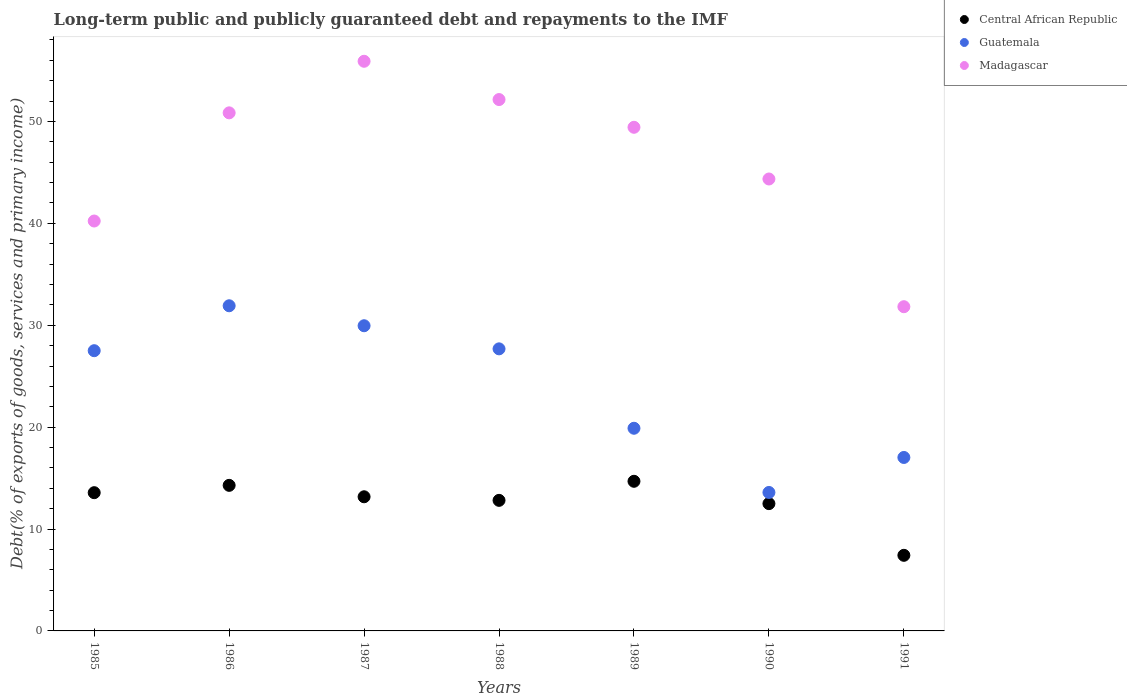What is the debt and repayments in Guatemala in 1990?
Provide a short and direct response. 13.59. Across all years, what is the maximum debt and repayments in Madagascar?
Make the answer very short. 55.91. Across all years, what is the minimum debt and repayments in Central African Republic?
Make the answer very short. 7.42. In which year was the debt and repayments in Madagascar maximum?
Ensure brevity in your answer.  1987. What is the total debt and repayments in Guatemala in the graph?
Keep it short and to the point. 167.56. What is the difference between the debt and repayments in Madagascar in 1987 and that in 1990?
Your response must be concise. 11.55. What is the difference between the debt and repayments in Central African Republic in 1985 and the debt and repayments in Guatemala in 1990?
Your answer should be compact. -0.02. What is the average debt and repayments in Guatemala per year?
Give a very brief answer. 23.94. In the year 1988, what is the difference between the debt and repayments in Madagascar and debt and repayments in Central African Republic?
Give a very brief answer. 39.34. In how many years, is the debt and repayments in Madagascar greater than 34 %?
Your answer should be compact. 6. What is the ratio of the debt and repayments in Guatemala in 1986 to that in 1987?
Make the answer very short. 1.07. Is the debt and repayments in Central African Republic in 1986 less than that in 1988?
Provide a succinct answer. No. Is the difference between the debt and repayments in Madagascar in 1986 and 1988 greater than the difference between the debt and repayments in Central African Republic in 1986 and 1988?
Keep it short and to the point. No. What is the difference between the highest and the second highest debt and repayments in Madagascar?
Offer a terse response. 3.76. What is the difference between the highest and the lowest debt and repayments in Guatemala?
Ensure brevity in your answer.  18.32. Is the sum of the debt and repayments in Madagascar in 1986 and 1988 greater than the maximum debt and repayments in Guatemala across all years?
Your answer should be very brief. Yes. Does the debt and repayments in Central African Republic monotonically increase over the years?
Your response must be concise. No. How many dotlines are there?
Provide a short and direct response. 3. What is the difference between two consecutive major ticks on the Y-axis?
Your answer should be compact. 10. Are the values on the major ticks of Y-axis written in scientific E-notation?
Provide a succinct answer. No. Does the graph contain any zero values?
Ensure brevity in your answer.  No. Where does the legend appear in the graph?
Provide a short and direct response. Top right. How are the legend labels stacked?
Your answer should be compact. Vertical. What is the title of the graph?
Your answer should be compact. Long-term public and publicly guaranteed debt and repayments to the IMF. Does "Other small states" appear as one of the legend labels in the graph?
Make the answer very short. No. What is the label or title of the Y-axis?
Make the answer very short. Debt(% of exports of goods, services and primary income). What is the Debt(% of exports of goods, services and primary income) in Central African Republic in 1985?
Your answer should be very brief. 13.57. What is the Debt(% of exports of goods, services and primary income) of Guatemala in 1985?
Keep it short and to the point. 27.5. What is the Debt(% of exports of goods, services and primary income) of Madagascar in 1985?
Make the answer very short. 40.23. What is the Debt(% of exports of goods, services and primary income) in Central African Republic in 1986?
Provide a succinct answer. 14.29. What is the Debt(% of exports of goods, services and primary income) of Guatemala in 1986?
Your response must be concise. 31.91. What is the Debt(% of exports of goods, services and primary income) of Madagascar in 1986?
Keep it short and to the point. 50.85. What is the Debt(% of exports of goods, services and primary income) in Central African Republic in 1987?
Your answer should be very brief. 13.17. What is the Debt(% of exports of goods, services and primary income) of Guatemala in 1987?
Keep it short and to the point. 29.95. What is the Debt(% of exports of goods, services and primary income) of Madagascar in 1987?
Your response must be concise. 55.91. What is the Debt(% of exports of goods, services and primary income) of Central African Republic in 1988?
Your answer should be very brief. 12.81. What is the Debt(% of exports of goods, services and primary income) of Guatemala in 1988?
Make the answer very short. 27.68. What is the Debt(% of exports of goods, services and primary income) in Madagascar in 1988?
Offer a very short reply. 52.15. What is the Debt(% of exports of goods, services and primary income) in Central African Republic in 1989?
Make the answer very short. 14.69. What is the Debt(% of exports of goods, services and primary income) of Guatemala in 1989?
Make the answer very short. 19.89. What is the Debt(% of exports of goods, services and primary income) of Madagascar in 1989?
Keep it short and to the point. 49.43. What is the Debt(% of exports of goods, services and primary income) in Central African Republic in 1990?
Your answer should be very brief. 12.49. What is the Debt(% of exports of goods, services and primary income) of Guatemala in 1990?
Provide a succinct answer. 13.59. What is the Debt(% of exports of goods, services and primary income) in Madagascar in 1990?
Your response must be concise. 44.36. What is the Debt(% of exports of goods, services and primary income) in Central African Republic in 1991?
Your answer should be very brief. 7.42. What is the Debt(% of exports of goods, services and primary income) in Guatemala in 1991?
Your answer should be compact. 17.02. What is the Debt(% of exports of goods, services and primary income) in Madagascar in 1991?
Make the answer very short. 31.82. Across all years, what is the maximum Debt(% of exports of goods, services and primary income) in Central African Republic?
Offer a very short reply. 14.69. Across all years, what is the maximum Debt(% of exports of goods, services and primary income) in Guatemala?
Your answer should be compact. 31.91. Across all years, what is the maximum Debt(% of exports of goods, services and primary income) of Madagascar?
Your answer should be very brief. 55.91. Across all years, what is the minimum Debt(% of exports of goods, services and primary income) in Central African Republic?
Your answer should be compact. 7.42. Across all years, what is the minimum Debt(% of exports of goods, services and primary income) in Guatemala?
Provide a succinct answer. 13.59. Across all years, what is the minimum Debt(% of exports of goods, services and primary income) of Madagascar?
Make the answer very short. 31.82. What is the total Debt(% of exports of goods, services and primary income) in Central African Republic in the graph?
Give a very brief answer. 88.44. What is the total Debt(% of exports of goods, services and primary income) in Guatemala in the graph?
Offer a terse response. 167.56. What is the total Debt(% of exports of goods, services and primary income) of Madagascar in the graph?
Ensure brevity in your answer.  324.75. What is the difference between the Debt(% of exports of goods, services and primary income) in Central African Republic in 1985 and that in 1986?
Give a very brief answer. -0.72. What is the difference between the Debt(% of exports of goods, services and primary income) in Guatemala in 1985 and that in 1986?
Your answer should be very brief. -4.41. What is the difference between the Debt(% of exports of goods, services and primary income) in Madagascar in 1985 and that in 1986?
Your answer should be very brief. -10.62. What is the difference between the Debt(% of exports of goods, services and primary income) in Central African Republic in 1985 and that in 1987?
Ensure brevity in your answer.  0.4. What is the difference between the Debt(% of exports of goods, services and primary income) of Guatemala in 1985 and that in 1987?
Your answer should be compact. -2.45. What is the difference between the Debt(% of exports of goods, services and primary income) in Madagascar in 1985 and that in 1987?
Make the answer very short. -15.68. What is the difference between the Debt(% of exports of goods, services and primary income) of Central African Republic in 1985 and that in 1988?
Provide a short and direct response. 0.75. What is the difference between the Debt(% of exports of goods, services and primary income) in Guatemala in 1985 and that in 1988?
Your answer should be very brief. -0.18. What is the difference between the Debt(% of exports of goods, services and primary income) of Madagascar in 1985 and that in 1988?
Your answer should be very brief. -11.92. What is the difference between the Debt(% of exports of goods, services and primary income) of Central African Republic in 1985 and that in 1989?
Provide a succinct answer. -1.12. What is the difference between the Debt(% of exports of goods, services and primary income) of Guatemala in 1985 and that in 1989?
Offer a terse response. 7.61. What is the difference between the Debt(% of exports of goods, services and primary income) of Madagascar in 1985 and that in 1989?
Give a very brief answer. -9.2. What is the difference between the Debt(% of exports of goods, services and primary income) in Central African Republic in 1985 and that in 1990?
Provide a short and direct response. 1.07. What is the difference between the Debt(% of exports of goods, services and primary income) of Guatemala in 1985 and that in 1990?
Offer a terse response. 13.91. What is the difference between the Debt(% of exports of goods, services and primary income) in Madagascar in 1985 and that in 1990?
Provide a succinct answer. -4.13. What is the difference between the Debt(% of exports of goods, services and primary income) in Central African Republic in 1985 and that in 1991?
Provide a succinct answer. 6.15. What is the difference between the Debt(% of exports of goods, services and primary income) in Guatemala in 1985 and that in 1991?
Your answer should be very brief. 10.48. What is the difference between the Debt(% of exports of goods, services and primary income) of Madagascar in 1985 and that in 1991?
Keep it short and to the point. 8.41. What is the difference between the Debt(% of exports of goods, services and primary income) of Central African Republic in 1986 and that in 1987?
Your response must be concise. 1.12. What is the difference between the Debt(% of exports of goods, services and primary income) of Guatemala in 1986 and that in 1987?
Your answer should be compact. 1.96. What is the difference between the Debt(% of exports of goods, services and primary income) of Madagascar in 1986 and that in 1987?
Your response must be concise. -5.06. What is the difference between the Debt(% of exports of goods, services and primary income) in Central African Republic in 1986 and that in 1988?
Offer a very short reply. 1.47. What is the difference between the Debt(% of exports of goods, services and primary income) of Guatemala in 1986 and that in 1988?
Your answer should be compact. 4.23. What is the difference between the Debt(% of exports of goods, services and primary income) in Madagascar in 1986 and that in 1988?
Give a very brief answer. -1.31. What is the difference between the Debt(% of exports of goods, services and primary income) in Central African Republic in 1986 and that in 1989?
Your answer should be compact. -0.4. What is the difference between the Debt(% of exports of goods, services and primary income) of Guatemala in 1986 and that in 1989?
Your answer should be compact. 12.02. What is the difference between the Debt(% of exports of goods, services and primary income) in Madagascar in 1986 and that in 1989?
Offer a very short reply. 1.42. What is the difference between the Debt(% of exports of goods, services and primary income) in Central African Republic in 1986 and that in 1990?
Make the answer very short. 1.79. What is the difference between the Debt(% of exports of goods, services and primary income) of Guatemala in 1986 and that in 1990?
Provide a succinct answer. 18.32. What is the difference between the Debt(% of exports of goods, services and primary income) in Madagascar in 1986 and that in 1990?
Offer a terse response. 6.49. What is the difference between the Debt(% of exports of goods, services and primary income) of Central African Republic in 1986 and that in 1991?
Provide a short and direct response. 6.87. What is the difference between the Debt(% of exports of goods, services and primary income) in Guatemala in 1986 and that in 1991?
Offer a terse response. 14.89. What is the difference between the Debt(% of exports of goods, services and primary income) of Madagascar in 1986 and that in 1991?
Give a very brief answer. 19.03. What is the difference between the Debt(% of exports of goods, services and primary income) in Central African Republic in 1987 and that in 1988?
Provide a succinct answer. 0.35. What is the difference between the Debt(% of exports of goods, services and primary income) in Guatemala in 1987 and that in 1988?
Keep it short and to the point. 2.27. What is the difference between the Debt(% of exports of goods, services and primary income) in Madagascar in 1987 and that in 1988?
Offer a very short reply. 3.76. What is the difference between the Debt(% of exports of goods, services and primary income) in Central African Republic in 1987 and that in 1989?
Keep it short and to the point. -1.52. What is the difference between the Debt(% of exports of goods, services and primary income) in Guatemala in 1987 and that in 1989?
Keep it short and to the point. 10.06. What is the difference between the Debt(% of exports of goods, services and primary income) of Madagascar in 1987 and that in 1989?
Your answer should be very brief. 6.48. What is the difference between the Debt(% of exports of goods, services and primary income) of Central African Republic in 1987 and that in 1990?
Offer a terse response. 0.67. What is the difference between the Debt(% of exports of goods, services and primary income) in Guatemala in 1987 and that in 1990?
Give a very brief answer. 16.36. What is the difference between the Debt(% of exports of goods, services and primary income) in Madagascar in 1987 and that in 1990?
Keep it short and to the point. 11.55. What is the difference between the Debt(% of exports of goods, services and primary income) in Central African Republic in 1987 and that in 1991?
Your answer should be very brief. 5.75. What is the difference between the Debt(% of exports of goods, services and primary income) of Guatemala in 1987 and that in 1991?
Give a very brief answer. 12.93. What is the difference between the Debt(% of exports of goods, services and primary income) in Madagascar in 1987 and that in 1991?
Offer a terse response. 24.09. What is the difference between the Debt(% of exports of goods, services and primary income) of Central African Republic in 1988 and that in 1989?
Your answer should be compact. -1.87. What is the difference between the Debt(% of exports of goods, services and primary income) in Guatemala in 1988 and that in 1989?
Provide a short and direct response. 7.79. What is the difference between the Debt(% of exports of goods, services and primary income) of Madagascar in 1988 and that in 1989?
Provide a short and direct response. 2.72. What is the difference between the Debt(% of exports of goods, services and primary income) of Central African Republic in 1988 and that in 1990?
Your answer should be very brief. 0.32. What is the difference between the Debt(% of exports of goods, services and primary income) in Guatemala in 1988 and that in 1990?
Your answer should be very brief. 14.09. What is the difference between the Debt(% of exports of goods, services and primary income) of Madagascar in 1988 and that in 1990?
Provide a short and direct response. 7.8. What is the difference between the Debt(% of exports of goods, services and primary income) of Central African Republic in 1988 and that in 1991?
Make the answer very short. 5.39. What is the difference between the Debt(% of exports of goods, services and primary income) of Guatemala in 1988 and that in 1991?
Keep it short and to the point. 10.66. What is the difference between the Debt(% of exports of goods, services and primary income) of Madagascar in 1988 and that in 1991?
Your answer should be very brief. 20.33. What is the difference between the Debt(% of exports of goods, services and primary income) of Central African Republic in 1989 and that in 1990?
Provide a succinct answer. 2.19. What is the difference between the Debt(% of exports of goods, services and primary income) in Guatemala in 1989 and that in 1990?
Your answer should be very brief. 6.3. What is the difference between the Debt(% of exports of goods, services and primary income) in Madagascar in 1989 and that in 1990?
Provide a succinct answer. 5.07. What is the difference between the Debt(% of exports of goods, services and primary income) in Central African Republic in 1989 and that in 1991?
Provide a short and direct response. 7.27. What is the difference between the Debt(% of exports of goods, services and primary income) of Guatemala in 1989 and that in 1991?
Make the answer very short. 2.87. What is the difference between the Debt(% of exports of goods, services and primary income) of Madagascar in 1989 and that in 1991?
Make the answer very short. 17.61. What is the difference between the Debt(% of exports of goods, services and primary income) of Central African Republic in 1990 and that in 1991?
Keep it short and to the point. 5.07. What is the difference between the Debt(% of exports of goods, services and primary income) in Guatemala in 1990 and that in 1991?
Ensure brevity in your answer.  -3.43. What is the difference between the Debt(% of exports of goods, services and primary income) in Madagascar in 1990 and that in 1991?
Give a very brief answer. 12.54. What is the difference between the Debt(% of exports of goods, services and primary income) of Central African Republic in 1985 and the Debt(% of exports of goods, services and primary income) of Guatemala in 1986?
Make the answer very short. -18.34. What is the difference between the Debt(% of exports of goods, services and primary income) in Central African Republic in 1985 and the Debt(% of exports of goods, services and primary income) in Madagascar in 1986?
Make the answer very short. -37.28. What is the difference between the Debt(% of exports of goods, services and primary income) in Guatemala in 1985 and the Debt(% of exports of goods, services and primary income) in Madagascar in 1986?
Offer a terse response. -23.34. What is the difference between the Debt(% of exports of goods, services and primary income) of Central African Republic in 1985 and the Debt(% of exports of goods, services and primary income) of Guatemala in 1987?
Give a very brief answer. -16.38. What is the difference between the Debt(% of exports of goods, services and primary income) in Central African Republic in 1985 and the Debt(% of exports of goods, services and primary income) in Madagascar in 1987?
Ensure brevity in your answer.  -42.34. What is the difference between the Debt(% of exports of goods, services and primary income) in Guatemala in 1985 and the Debt(% of exports of goods, services and primary income) in Madagascar in 1987?
Keep it short and to the point. -28.41. What is the difference between the Debt(% of exports of goods, services and primary income) of Central African Republic in 1985 and the Debt(% of exports of goods, services and primary income) of Guatemala in 1988?
Offer a terse response. -14.12. What is the difference between the Debt(% of exports of goods, services and primary income) of Central African Republic in 1985 and the Debt(% of exports of goods, services and primary income) of Madagascar in 1988?
Provide a succinct answer. -38.59. What is the difference between the Debt(% of exports of goods, services and primary income) of Guatemala in 1985 and the Debt(% of exports of goods, services and primary income) of Madagascar in 1988?
Offer a terse response. -24.65. What is the difference between the Debt(% of exports of goods, services and primary income) of Central African Republic in 1985 and the Debt(% of exports of goods, services and primary income) of Guatemala in 1989?
Keep it short and to the point. -6.32. What is the difference between the Debt(% of exports of goods, services and primary income) of Central African Republic in 1985 and the Debt(% of exports of goods, services and primary income) of Madagascar in 1989?
Your response must be concise. -35.86. What is the difference between the Debt(% of exports of goods, services and primary income) of Guatemala in 1985 and the Debt(% of exports of goods, services and primary income) of Madagascar in 1989?
Provide a succinct answer. -21.93. What is the difference between the Debt(% of exports of goods, services and primary income) of Central African Republic in 1985 and the Debt(% of exports of goods, services and primary income) of Guatemala in 1990?
Provide a short and direct response. -0.02. What is the difference between the Debt(% of exports of goods, services and primary income) in Central African Republic in 1985 and the Debt(% of exports of goods, services and primary income) in Madagascar in 1990?
Offer a terse response. -30.79. What is the difference between the Debt(% of exports of goods, services and primary income) in Guatemala in 1985 and the Debt(% of exports of goods, services and primary income) in Madagascar in 1990?
Provide a succinct answer. -16.85. What is the difference between the Debt(% of exports of goods, services and primary income) in Central African Republic in 1985 and the Debt(% of exports of goods, services and primary income) in Guatemala in 1991?
Ensure brevity in your answer.  -3.46. What is the difference between the Debt(% of exports of goods, services and primary income) in Central African Republic in 1985 and the Debt(% of exports of goods, services and primary income) in Madagascar in 1991?
Your answer should be compact. -18.25. What is the difference between the Debt(% of exports of goods, services and primary income) of Guatemala in 1985 and the Debt(% of exports of goods, services and primary income) of Madagascar in 1991?
Ensure brevity in your answer.  -4.32. What is the difference between the Debt(% of exports of goods, services and primary income) in Central African Republic in 1986 and the Debt(% of exports of goods, services and primary income) in Guatemala in 1987?
Give a very brief answer. -15.67. What is the difference between the Debt(% of exports of goods, services and primary income) of Central African Republic in 1986 and the Debt(% of exports of goods, services and primary income) of Madagascar in 1987?
Ensure brevity in your answer.  -41.62. What is the difference between the Debt(% of exports of goods, services and primary income) of Guatemala in 1986 and the Debt(% of exports of goods, services and primary income) of Madagascar in 1987?
Your answer should be compact. -24. What is the difference between the Debt(% of exports of goods, services and primary income) in Central African Republic in 1986 and the Debt(% of exports of goods, services and primary income) in Guatemala in 1988?
Give a very brief answer. -13.4. What is the difference between the Debt(% of exports of goods, services and primary income) of Central African Republic in 1986 and the Debt(% of exports of goods, services and primary income) of Madagascar in 1988?
Ensure brevity in your answer.  -37.87. What is the difference between the Debt(% of exports of goods, services and primary income) of Guatemala in 1986 and the Debt(% of exports of goods, services and primary income) of Madagascar in 1988?
Keep it short and to the point. -20.24. What is the difference between the Debt(% of exports of goods, services and primary income) of Central African Republic in 1986 and the Debt(% of exports of goods, services and primary income) of Guatemala in 1989?
Give a very brief answer. -5.6. What is the difference between the Debt(% of exports of goods, services and primary income) in Central African Republic in 1986 and the Debt(% of exports of goods, services and primary income) in Madagascar in 1989?
Provide a succinct answer. -35.14. What is the difference between the Debt(% of exports of goods, services and primary income) in Guatemala in 1986 and the Debt(% of exports of goods, services and primary income) in Madagascar in 1989?
Provide a short and direct response. -17.52. What is the difference between the Debt(% of exports of goods, services and primary income) in Central African Republic in 1986 and the Debt(% of exports of goods, services and primary income) in Guatemala in 1990?
Ensure brevity in your answer.  0.7. What is the difference between the Debt(% of exports of goods, services and primary income) of Central African Republic in 1986 and the Debt(% of exports of goods, services and primary income) of Madagascar in 1990?
Your response must be concise. -30.07. What is the difference between the Debt(% of exports of goods, services and primary income) of Guatemala in 1986 and the Debt(% of exports of goods, services and primary income) of Madagascar in 1990?
Your answer should be compact. -12.44. What is the difference between the Debt(% of exports of goods, services and primary income) in Central African Republic in 1986 and the Debt(% of exports of goods, services and primary income) in Guatemala in 1991?
Your answer should be compact. -2.74. What is the difference between the Debt(% of exports of goods, services and primary income) in Central African Republic in 1986 and the Debt(% of exports of goods, services and primary income) in Madagascar in 1991?
Your answer should be compact. -17.53. What is the difference between the Debt(% of exports of goods, services and primary income) of Guatemala in 1986 and the Debt(% of exports of goods, services and primary income) of Madagascar in 1991?
Your response must be concise. 0.09. What is the difference between the Debt(% of exports of goods, services and primary income) in Central African Republic in 1987 and the Debt(% of exports of goods, services and primary income) in Guatemala in 1988?
Keep it short and to the point. -14.52. What is the difference between the Debt(% of exports of goods, services and primary income) in Central African Republic in 1987 and the Debt(% of exports of goods, services and primary income) in Madagascar in 1988?
Provide a short and direct response. -38.99. What is the difference between the Debt(% of exports of goods, services and primary income) in Guatemala in 1987 and the Debt(% of exports of goods, services and primary income) in Madagascar in 1988?
Your response must be concise. -22.2. What is the difference between the Debt(% of exports of goods, services and primary income) in Central African Republic in 1987 and the Debt(% of exports of goods, services and primary income) in Guatemala in 1989?
Give a very brief answer. -6.72. What is the difference between the Debt(% of exports of goods, services and primary income) of Central African Republic in 1987 and the Debt(% of exports of goods, services and primary income) of Madagascar in 1989?
Make the answer very short. -36.26. What is the difference between the Debt(% of exports of goods, services and primary income) in Guatemala in 1987 and the Debt(% of exports of goods, services and primary income) in Madagascar in 1989?
Keep it short and to the point. -19.48. What is the difference between the Debt(% of exports of goods, services and primary income) in Central African Republic in 1987 and the Debt(% of exports of goods, services and primary income) in Guatemala in 1990?
Give a very brief answer. -0.42. What is the difference between the Debt(% of exports of goods, services and primary income) in Central African Republic in 1987 and the Debt(% of exports of goods, services and primary income) in Madagascar in 1990?
Your response must be concise. -31.19. What is the difference between the Debt(% of exports of goods, services and primary income) of Guatemala in 1987 and the Debt(% of exports of goods, services and primary income) of Madagascar in 1990?
Your answer should be compact. -14.4. What is the difference between the Debt(% of exports of goods, services and primary income) of Central African Republic in 1987 and the Debt(% of exports of goods, services and primary income) of Guatemala in 1991?
Your answer should be compact. -3.86. What is the difference between the Debt(% of exports of goods, services and primary income) in Central African Republic in 1987 and the Debt(% of exports of goods, services and primary income) in Madagascar in 1991?
Keep it short and to the point. -18.65. What is the difference between the Debt(% of exports of goods, services and primary income) in Guatemala in 1987 and the Debt(% of exports of goods, services and primary income) in Madagascar in 1991?
Ensure brevity in your answer.  -1.87. What is the difference between the Debt(% of exports of goods, services and primary income) of Central African Republic in 1988 and the Debt(% of exports of goods, services and primary income) of Guatemala in 1989?
Ensure brevity in your answer.  -7.08. What is the difference between the Debt(% of exports of goods, services and primary income) of Central African Republic in 1988 and the Debt(% of exports of goods, services and primary income) of Madagascar in 1989?
Offer a very short reply. -36.62. What is the difference between the Debt(% of exports of goods, services and primary income) of Guatemala in 1988 and the Debt(% of exports of goods, services and primary income) of Madagascar in 1989?
Provide a succinct answer. -21.75. What is the difference between the Debt(% of exports of goods, services and primary income) in Central African Republic in 1988 and the Debt(% of exports of goods, services and primary income) in Guatemala in 1990?
Give a very brief answer. -0.78. What is the difference between the Debt(% of exports of goods, services and primary income) in Central African Republic in 1988 and the Debt(% of exports of goods, services and primary income) in Madagascar in 1990?
Make the answer very short. -31.54. What is the difference between the Debt(% of exports of goods, services and primary income) of Guatemala in 1988 and the Debt(% of exports of goods, services and primary income) of Madagascar in 1990?
Ensure brevity in your answer.  -16.67. What is the difference between the Debt(% of exports of goods, services and primary income) in Central African Republic in 1988 and the Debt(% of exports of goods, services and primary income) in Guatemala in 1991?
Give a very brief answer. -4.21. What is the difference between the Debt(% of exports of goods, services and primary income) in Central African Republic in 1988 and the Debt(% of exports of goods, services and primary income) in Madagascar in 1991?
Provide a succinct answer. -19.01. What is the difference between the Debt(% of exports of goods, services and primary income) in Guatemala in 1988 and the Debt(% of exports of goods, services and primary income) in Madagascar in 1991?
Offer a very short reply. -4.14. What is the difference between the Debt(% of exports of goods, services and primary income) in Central African Republic in 1989 and the Debt(% of exports of goods, services and primary income) in Guatemala in 1990?
Your answer should be very brief. 1.1. What is the difference between the Debt(% of exports of goods, services and primary income) in Central African Republic in 1989 and the Debt(% of exports of goods, services and primary income) in Madagascar in 1990?
Provide a succinct answer. -29.67. What is the difference between the Debt(% of exports of goods, services and primary income) of Guatemala in 1989 and the Debt(% of exports of goods, services and primary income) of Madagascar in 1990?
Your answer should be compact. -24.47. What is the difference between the Debt(% of exports of goods, services and primary income) in Central African Republic in 1989 and the Debt(% of exports of goods, services and primary income) in Guatemala in 1991?
Provide a short and direct response. -2.34. What is the difference between the Debt(% of exports of goods, services and primary income) in Central African Republic in 1989 and the Debt(% of exports of goods, services and primary income) in Madagascar in 1991?
Make the answer very short. -17.13. What is the difference between the Debt(% of exports of goods, services and primary income) of Guatemala in 1989 and the Debt(% of exports of goods, services and primary income) of Madagascar in 1991?
Ensure brevity in your answer.  -11.93. What is the difference between the Debt(% of exports of goods, services and primary income) in Central African Republic in 1990 and the Debt(% of exports of goods, services and primary income) in Guatemala in 1991?
Your response must be concise. -4.53. What is the difference between the Debt(% of exports of goods, services and primary income) in Central African Republic in 1990 and the Debt(% of exports of goods, services and primary income) in Madagascar in 1991?
Keep it short and to the point. -19.33. What is the difference between the Debt(% of exports of goods, services and primary income) in Guatemala in 1990 and the Debt(% of exports of goods, services and primary income) in Madagascar in 1991?
Give a very brief answer. -18.23. What is the average Debt(% of exports of goods, services and primary income) of Central African Republic per year?
Give a very brief answer. 12.63. What is the average Debt(% of exports of goods, services and primary income) in Guatemala per year?
Your response must be concise. 23.94. What is the average Debt(% of exports of goods, services and primary income) in Madagascar per year?
Offer a very short reply. 46.39. In the year 1985, what is the difference between the Debt(% of exports of goods, services and primary income) of Central African Republic and Debt(% of exports of goods, services and primary income) of Guatemala?
Your answer should be compact. -13.94. In the year 1985, what is the difference between the Debt(% of exports of goods, services and primary income) of Central African Republic and Debt(% of exports of goods, services and primary income) of Madagascar?
Your answer should be compact. -26.66. In the year 1985, what is the difference between the Debt(% of exports of goods, services and primary income) in Guatemala and Debt(% of exports of goods, services and primary income) in Madagascar?
Your answer should be very brief. -12.73. In the year 1986, what is the difference between the Debt(% of exports of goods, services and primary income) in Central African Republic and Debt(% of exports of goods, services and primary income) in Guatemala?
Make the answer very short. -17.63. In the year 1986, what is the difference between the Debt(% of exports of goods, services and primary income) of Central African Republic and Debt(% of exports of goods, services and primary income) of Madagascar?
Keep it short and to the point. -36.56. In the year 1986, what is the difference between the Debt(% of exports of goods, services and primary income) in Guatemala and Debt(% of exports of goods, services and primary income) in Madagascar?
Make the answer very short. -18.93. In the year 1987, what is the difference between the Debt(% of exports of goods, services and primary income) in Central African Republic and Debt(% of exports of goods, services and primary income) in Guatemala?
Make the answer very short. -16.79. In the year 1987, what is the difference between the Debt(% of exports of goods, services and primary income) of Central African Republic and Debt(% of exports of goods, services and primary income) of Madagascar?
Offer a very short reply. -42.74. In the year 1987, what is the difference between the Debt(% of exports of goods, services and primary income) of Guatemala and Debt(% of exports of goods, services and primary income) of Madagascar?
Your response must be concise. -25.96. In the year 1988, what is the difference between the Debt(% of exports of goods, services and primary income) in Central African Republic and Debt(% of exports of goods, services and primary income) in Guatemala?
Ensure brevity in your answer.  -14.87. In the year 1988, what is the difference between the Debt(% of exports of goods, services and primary income) in Central African Republic and Debt(% of exports of goods, services and primary income) in Madagascar?
Give a very brief answer. -39.34. In the year 1988, what is the difference between the Debt(% of exports of goods, services and primary income) in Guatemala and Debt(% of exports of goods, services and primary income) in Madagascar?
Offer a terse response. -24.47. In the year 1989, what is the difference between the Debt(% of exports of goods, services and primary income) in Central African Republic and Debt(% of exports of goods, services and primary income) in Guatemala?
Give a very brief answer. -5.2. In the year 1989, what is the difference between the Debt(% of exports of goods, services and primary income) of Central African Republic and Debt(% of exports of goods, services and primary income) of Madagascar?
Offer a terse response. -34.74. In the year 1989, what is the difference between the Debt(% of exports of goods, services and primary income) of Guatemala and Debt(% of exports of goods, services and primary income) of Madagascar?
Provide a short and direct response. -29.54. In the year 1990, what is the difference between the Debt(% of exports of goods, services and primary income) in Central African Republic and Debt(% of exports of goods, services and primary income) in Guatemala?
Provide a succinct answer. -1.1. In the year 1990, what is the difference between the Debt(% of exports of goods, services and primary income) of Central African Republic and Debt(% of exports of goods, services and primary income) of Madagascar?
Your response must be concise. -31.86. In the year 1990, what is the difference between the Debt(% of exports of goods, services and primary income) in Guatemala and Debt(% of exports of goods, services and primary income) in Madagascar?
Make the answer very short. -30.77. In the year 1991, what is the difference between the Debt(% of exports of goods, services and primary income) of Central African Republic and Debt(% of exports of goods, services and primary income) of Guatemala?
Provide a succinct answer. -9.6. In the year 1991, what is the difference between the Debt(% of exports of goods, services and primary income) in Central African Republic and Debt(% of exports of goods, services and primary income) in Madagascar?
Offer a terse response. -24.4. In the year 1991, what is the difference between the Debt(% of exports of goods, services and primary income) in Guatemala and Debt(% of exports of goods, services and primary income) in Madagascar?
Offer a very short reply. -14.8. What is the ratio of the Debt(% of exports of goods, services and primary income) of Central African Republic in 1985 to that in 1986?
Give a very brief answer. 0.95. What is the ratio of the Debt(% of exports of goods, services and primary income) in Guatemala in 1985 to that in 1986?
Keep it short and to the point. 0.86. What is the ratio of the Debt(% of exports of goods, services and primary income) in Madagascar in 1985 to that in 1986?
Offer a terse response. 0.79. What is the ratio of the Debt(% of exports of goods, services and primary income) in Central African Republic in 1985 to that in 1987?
Offer a terse response. 1.03. What is the ratio of the Debt(% of exports of goods, services and primary income) of Guatemala in 1985 to that in 1987?
Make the answer very short. 0.92. What is the ratio of the Debt(% of exports of goods, services and primary income) of Madagascar in 1985 to that in 1987?
Keep it short and to the point. 0.72. What is the ratio of the Debt(% of exports of goods, services and primary income) in Central African Republic in 1985 to that in 1988?
Provide a succinct answer. 1.06. What is the ratio of the Debt(% of exports of goods, services and primary income) of Guatemala in 1985 to that in 1988?
Give a very brief answer. 0.99. What is the ratio of the Debt(% of exports of goods, services and primary income) in Madagascar in 1985 to that in 1988?
Your answer should be compact. 0.77. What is the ratio of the Debt(% of exports of goods, services and primary income) of Central African Republic in 1985 to that in 1989?
Keep it short and to the point. 0.92. What is the ratio of the Debt(% of exports of goods, services and primary income) of Guatemala in 1985 to that in 1989?
Provide a short and direct response. 1.38. What is the ratio of the Debt(% of exports of goods, services and primary income) of Madagascar in 1985 to that in 1989?
Your answer should be compact. 0.81. What is the ratio of the Debt(% of exports of goods, services and primary income) in Central African Republic in 1985 to that in 1990?
Offer a terse response. 1.09. What is the ratio of the Debt(% of exports of goods, services and primary income) in Guatemala in 1985 to that in 1990?
Your answer should be compact. 2.02. What is the ratio of the Debt(% of exports of goods, services and primary income) of Madagascar in 1985 to that in 1990?
Your response must be concise. 0.91. What is the ratio of the Debt(% of exports of goods, services and primary income) of Central African Republic in 1985 to that in 1991?
Make the answer very short. 1.83. What is the ratio of the Debt(% of exports of goods, services and primary income) in Guatemala in 1985 to that in 1991?
Offer a very short reply. 1.62. What is the ratio of the Debt(% of exports of goods, services and primary income) of Madagascar in 1985 to that in 1991?
Ensure brevity in your answer.  1.26. What is the ratio of the Debt(% of exports of goods, services and primary income) in Central African Republic in 1986 to that in 1987?
Ensure brevity in your answer.  1.09. What is the ratio of the Debt(% of exports of goods, services and primary income) in Guatemala in 1986 to that in 1987?
Offer a terse response. 1.07. What is the ratio of the Debt(% of exports of goods, services and primary income) of Madagascar in 1986 to that in 1987?
Offer a very short reply. 0.91. What is the ratio of the Debt(% of exports of goods, services and primary income) of Central African Republic in 1986 to that in 1988?
Your answer should be very brief. 1.11. What is the ratio of the Debt(% of exports of goods, services and primary income) in Guatemala in 1986 to that in 1988?
Give a very brief answer. 1.15. What is the ratio of the Debt(% of exports of goods, services and primary income) in Madagascar in 1986 to that in 1988?
Your answer should be very brief. 0.97. What is the ratio of the Debt(% of exports of goods, services and primary income) in Central African Republic in 1986 to that in 1989?
Your answer should be compact. 0.97. What is the ratio of the Debt(% of exports of goods, services and primary income) of Guatemala in 1986 to that in 1989?
Your response must be concise. 1.6. What is the ratio of the Debt(% of exports of goods, services and primary income) in Madagascar in 1986 to that in 1989?
Your answer should be compact. 1.03. What is the ratio of the Debt(% of exports of goods, services and primary income) in Central African Republic in 1986 to that in 1990?
Provide a succinct answer. 1.14. What is the ratio of the Debt(% of exports of goods, services and primary income) in Guatemala in 1986 to that in 1990?
Offer a terse response. 2.35. What is the ratio of the Debt(% of exports of goods, services and primary income) of Madagascar in 1986 to that in 1990?
Offer a very short reply. 1.15. What is the ratio of the Debt(% of exports of goods, services and primary income) of Central African Republic in 1986 to that in 1991?
Your response must be concise. 1.93. What is the ratio of the Debt(% of exports of goods, services and primary income) of Guatemala in 1986 to that in 1991?
Offer a terse response. 1.87. What is the ratio of the Debt(% of exports of goods, services and primary income) of Madagascar in 1986 to that in 1991?
Ensure brevity in your answer.  1.6. What is the ratio of the Debt(% of exports of goods, services and primary income) in Central African Republic in 1987 to that in 1988?
Offer a terse response. 1.03. What is the ratio of the Debt(% of exports of goods, services and primary income) in Guatemala in 1987 to that in 1988?
Offer a very short reply. 1.08. What is the ratio of the Debt(% of exports of goods, services and primary income) of Madagascar in 1987 to that in 1988?
Offer a terse response. 1.07. What is the ratio of the Debt(% of exports of goods, services and primary income) of Central African Republic in 1987 to that in 1989?
Offer a very short reply. 0.9. What is the ratio of the Debt(% of exports of goods, services and primary income) of Guatemala in 1987 to that in 1989?
Your answer should be compact. 1.51. What is the ratio of the Debt(% of exports of goods, services and primary income) of Madagascar in 1987 to that in 1989?
Your answer should be compact. 1.13. What is the ratio of the Debt(% of exports of goods, services and primary income) in Central African Republic in 1987 to that in 1990?
Your answer should be very brief. 1.05. What is the ratio of the Debt(% of exports of goods, services and primary income) of Guatemala in 1987 to that in 1990?
Your answer should be compact. 2.2. What is the ratio of the Debt(% of exports of goods, services and primary income) in Madagascar in 1987 to that in 1990?
Provide a short and direct response. 1.26. What is the ratio of the Debt(% of exports of goods, services and primary income) of Central African Republic in 1987 to that in 1991?
Your answer should be compact. 1.77. What is the ratio of the Debt(% of exports of goods, services and primary income) in Guatemala in 1987 to that in 1991?
Offer a very short reply. 1.76. What is the ratio of the Debt(% of exports of goods, services and primary income) in Madagascar in 1987 to that in 1991?
Offer a very short reply. 1.76. What is the ratio of the Debt(% of exports of goods, services and primary income) in Central African Republic in 1988 to that in 1989?
Offer a terse response. 0.87. What is the ratio of the Debt(% of exports of goods, services and primary income) in Guatemala in 1988 to that in 1989?
Make the answer very short. 1.39. What is the ratio of the Debt(% of exports of goods, services and primary income) of Madagascar in 1988 to that in 1989?
Provide a succinct answer. 1.06. What is the ratio of the Debt(% of exports of goods, services and primary income) in Central African Republic in 1988 to that in 1990?
Your answer should be compact. 1.03. What is the ratio of the Debt(% of exports of goods, services and primary income) of Guatemala in 1988 to that in 1990?
Your response must be concise. 2.04. What is the ratio of the Debt(% of exports of goods, services and primary income) in Madagascar in 1988 to that in 1990?
Keep it short and to the point. 1.18. What is the ratio of the Debt(% of exports of goods, services and primary income) in Central African Republic in 1988 to that in 1991?
Ensure brevity in your answer.  1.73. What is the ratio of the Debt(% of exports of goods, services and primary income) in Guatemala in 1988 to that in 1991?
Give a very brief answer. 1.63. What is the ratio of the Debt(% of exports of goods, services and primary income) in Madagascar in 1988 to that in 1991?
Provide a succinct answer. 1.64. What is the ratio of the Debt(% of exports of goods, services and primary income) of Central African Republic in 1989 to that in 1990?
Make the answer very short. 1.18. What is the ratio of the Debt(% of exports of goods, services and primary income) in Guatemala in 1989 to that in 1990?
Ensure brevity in your answer.  1.46. What is the ratio of the Debt(% of exports of goods, services and primary income) in Madagascar in 1989 to that in 1990?
Offer a terse response. 1.11. What is the ratio of the Debt(% of exports of goods, services and primary income) in Central African Republic in 1989 to that in 1991?
Make the answer very short. 1.98. What is the ratio of the Debt(% of exports of goods, services and primary income) of Guatemala in 1989 to that in 1991?
Keep it short and to the point. 1.17. What is the ratio of the Debt(% of exports of goods, services and primary income) of Madagascar in 1989 to that in 1991?
Keep it short and to the point. 1.55. What is the ratio of the Debt(% of exports of goods, services and primary income) of Central African Republic in 1990 to that in 1991?
Provide a short and direct response. 1.68. What is the ratio of the Debt(% of exports of goods, services and primary income) in Guatemala in 1990 to that in 1991?
Make the answer very short. 0.8. What is the ratio of the Debt(% of exports of goods, services and primary income) in Madagascar in 1990 to that in 1991?
Offer a very short reply. 1.39. What is the difference between the highest and the second highest Debt(% of exports of goods, services and primary income) of Central African Republic?
Your response must be concise. 0.4. What is the difference between the highest and the second highest Debt(% of exports of goods, services and primary income) in Guatemala?
Your answer should be compact. 1.96. What is the difference between the highest and the second highest Debt(% of exports of goods, services and primary income) of Madagascar?
Provide a succinct answer. 3.76. What is the difference between the highest and the lowest Debt(% of exports of goods, services and primary income) in Central African Republic?
Your answer should be compact. 7.27. What is the difference between the highest and the lowest Debt(% of exports of goods, services and primary income) of Guatemala?
Your answer should be compact. 18.32. What is the difference between the highest and the lowest Debt(% of exports of goods, services and primary income) of Madagascar?
Make the answer very short. 24.09. 